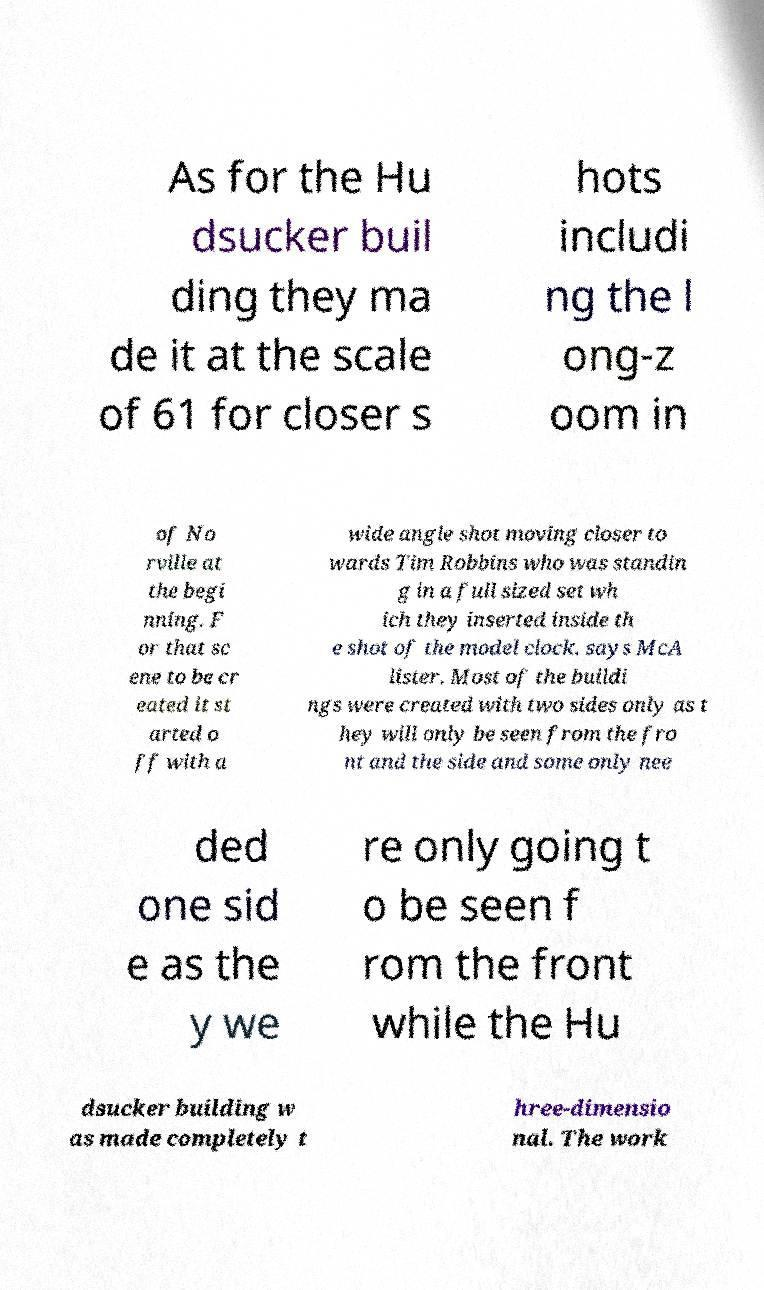There's text embedded in this image that I need extracted. Can you transcribe it verbatim? As for the Hu dsucker buil ding they ma de it at the scale of 61 for closer s hots includi ng the l ong-z oom in of No rville at the begi nning. F or that sc ene to be cr eated it st arted o ff with a wide angle shot moving closer to wards Tim Robbins who was standin g in a full sized set wh ich they inserted inside th e shot of the model clock. says McA lister. Most of the buildi ngs were created with two sides only as t hey will only be seen from the fro nt and the side and some only nee ded one sid e as the y we re only going t o be seen f rom the front while the Hu dsucker building w as made completely t hree-dimensio nal. The work 